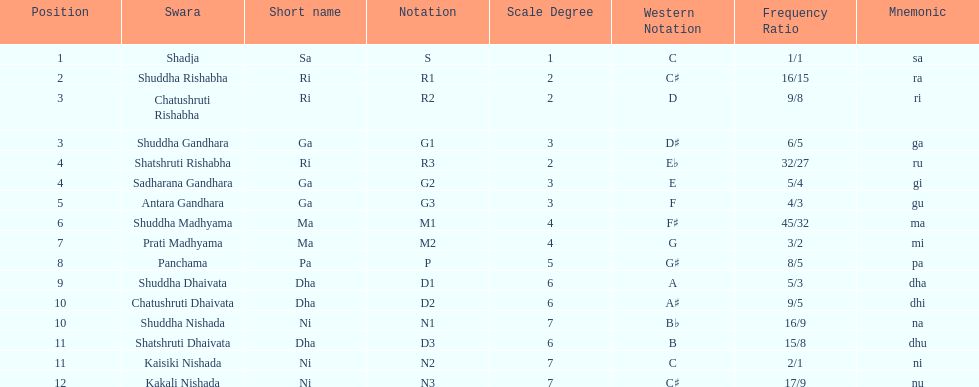How many swaras do not have dhaivata in their name? 13. 